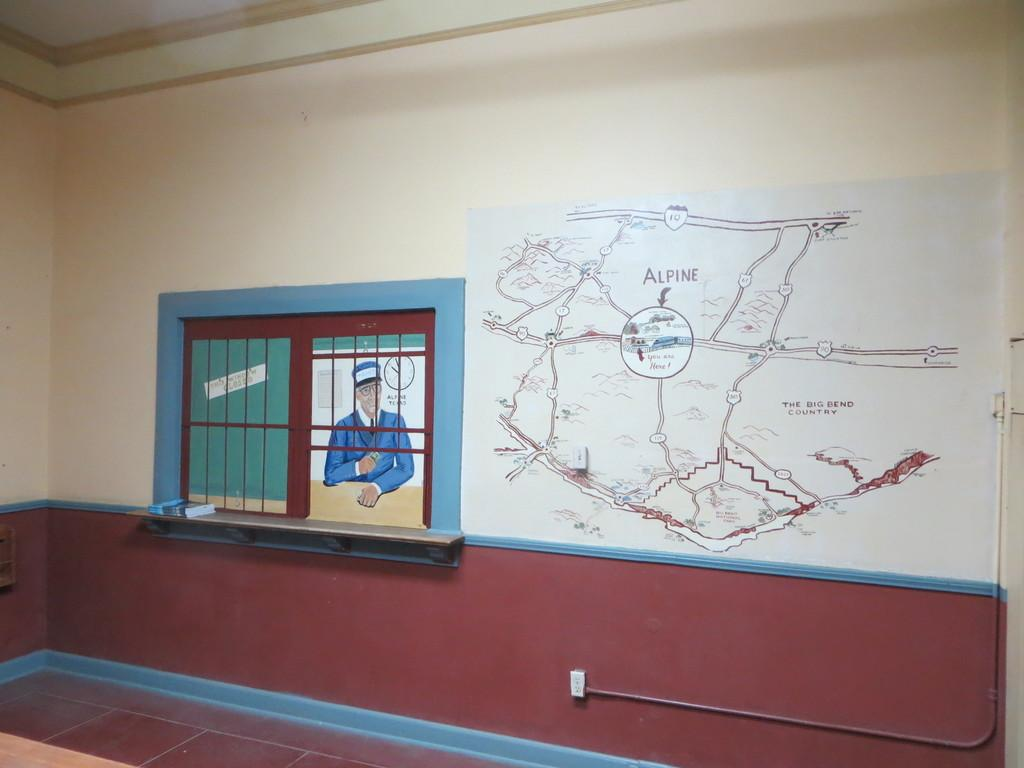What is located in the foreground of the image? There is a wall in the foreground of the image. What is depicted on the wall? There is a painting and a map on the wall. What part of the room can be seen above the wall? The ceiling is visible in the image. What type of wrench is being used to adjust the painting on the wall in the image? There is no wrench present in the image, and the painting is not being adjusted. 